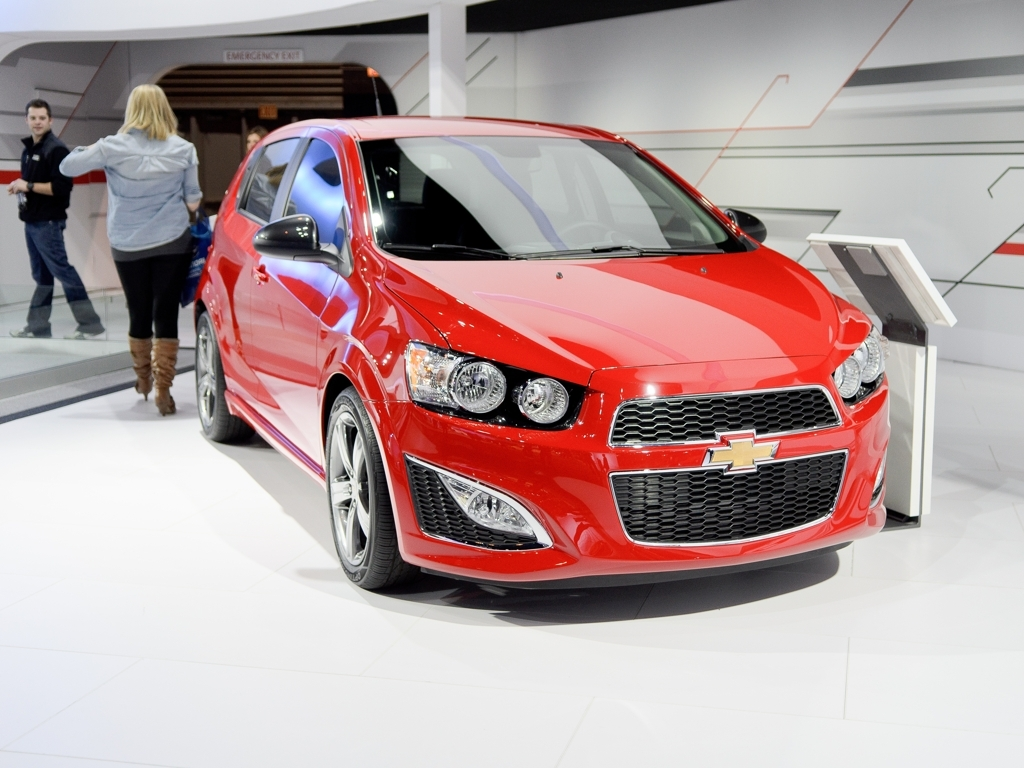Can you tell me what model this car is? While I cannot give specifics such as make or model, I can describe the visible elements. The car has a sporty hatchback design, with a prominent grille and sleek headlamps, indicative of a modern, compact car aimed at urban drivers who value both style and functionality. 